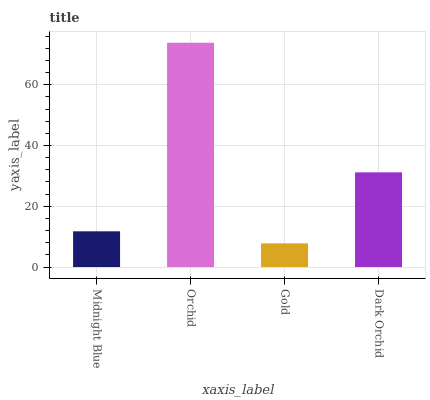Is Gold the minimum?
Answer yes or no. Yes. Is Orchid the maximum?
Answer yes or no. Yes. Is Orchid the minimum?
Answer yes or no. No. Is Gold the maximum?
Answer yes or no. No. Is Orchid greater than Gold?
Answer yes or no. Yes. Is Gold less than Orchid?
Answer yes or no. Yes. Is Gold greater than Orchid?
Answer yes or no. No. Is Orchid less than Gold?
Answer yes or no. No. Is Dark Orchid the high median?
Answer yes or no. Yes. Is Midnight Blue the low median?
Answer yes or no. Yes. Is Midnight Blue the high median?
Answer yes or no. No. Is Gold the low median?
Answer yes or no. No. 